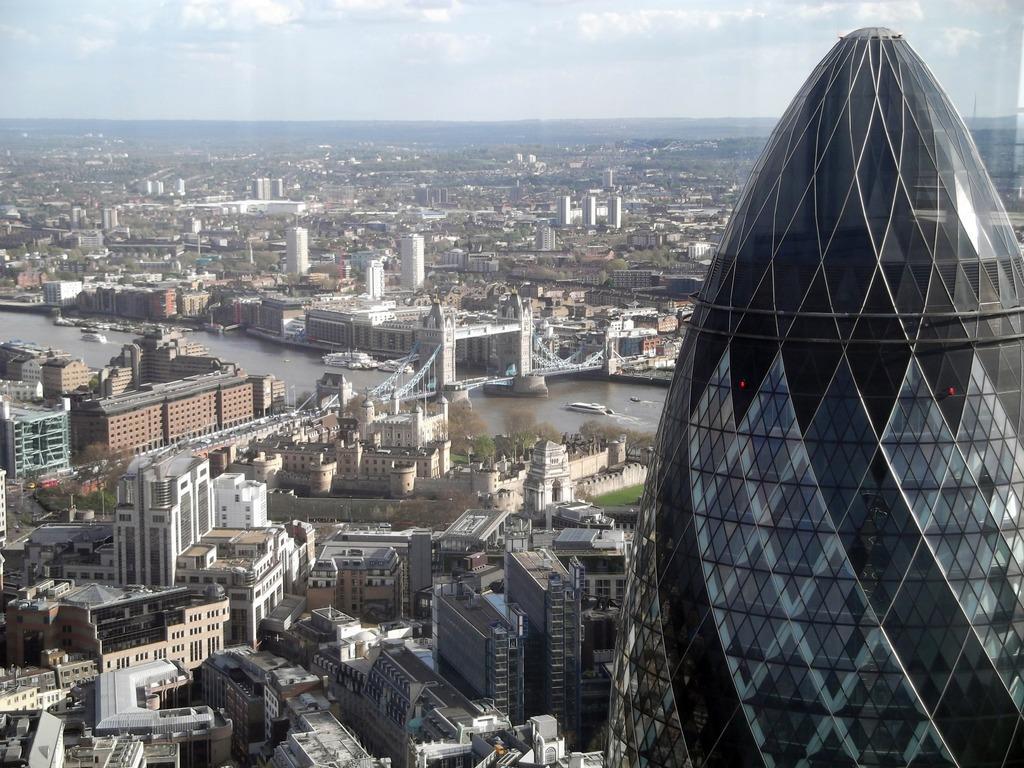How would you summarize this image in a sentence or two? In this image at the bottom, there are buildings, trees, boats, water, bridge. On the right there is a tower. At the top there are sky and clouds. 